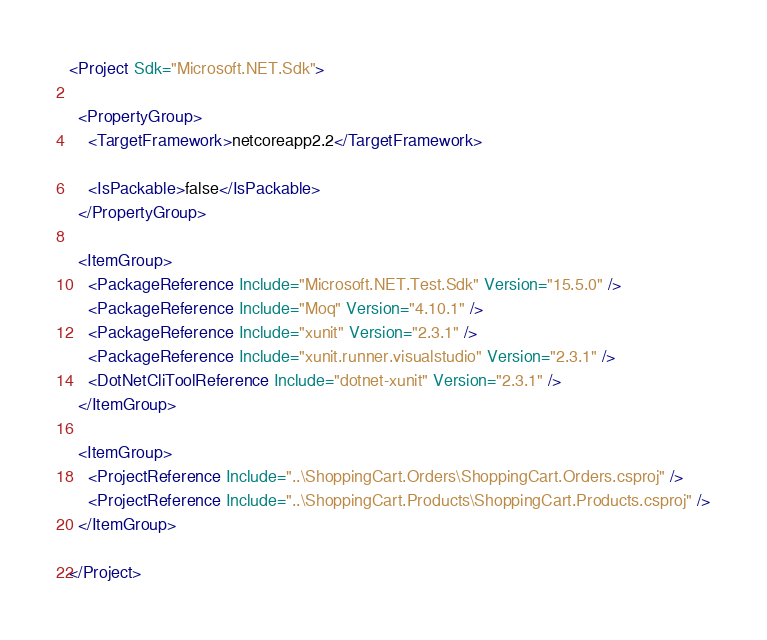<code> <loc_0><loc_0><loc_500><loc_500><_XML_><Project Sdk="Microsoft.NET.Sdk">

  <PropertyGroup>
    <TargetFramework>netcoreapp2.2</TargetFramework>

    <IsPackable>false</IsPackable>
  </PropertyGroup>

  <ItemGroup>
    <PackageReference Include="Microsoft.NET.Test.Sdk" Version="15.5.0" />
    <PackageReference Include="Moq" Version="4.10.1" />
    <PackageReference Include="xunit" Version="2.3.1" />
    <PackageReference Include="xunit.runner.visualstudio" Version="2.3.1" />
    <DotNetCliToolReference Include="dotnet-xunit" Version="2.3.1" />
  </ItemGroup>

  <ItemGroup>
    <ProjectReference Include="..\ShoppingCart.Orders\ShoppingCart.Orders.csproj" />
    <ProjectReference Include="..\ShoppingCart.Products\ShoppingCart.Products.csproj" />
  </ItemGroup>

</Project>
</code> 